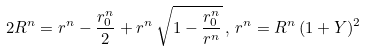<formula> <loc_0><loc_0><loc_500><loc_500>2 R ^ { n } = r ^ { n } - \frac { r _ { 0 } ^ { n } } { 2 } + r ^ { n } \, \sqrt { 1 - \frac { r _ { 0 } ^ { n } } { r ^ { n } } } \, , \, r ^ { n } = R ^ { n } \, ( 1 + Y ) ^ { 2 }</formula> 